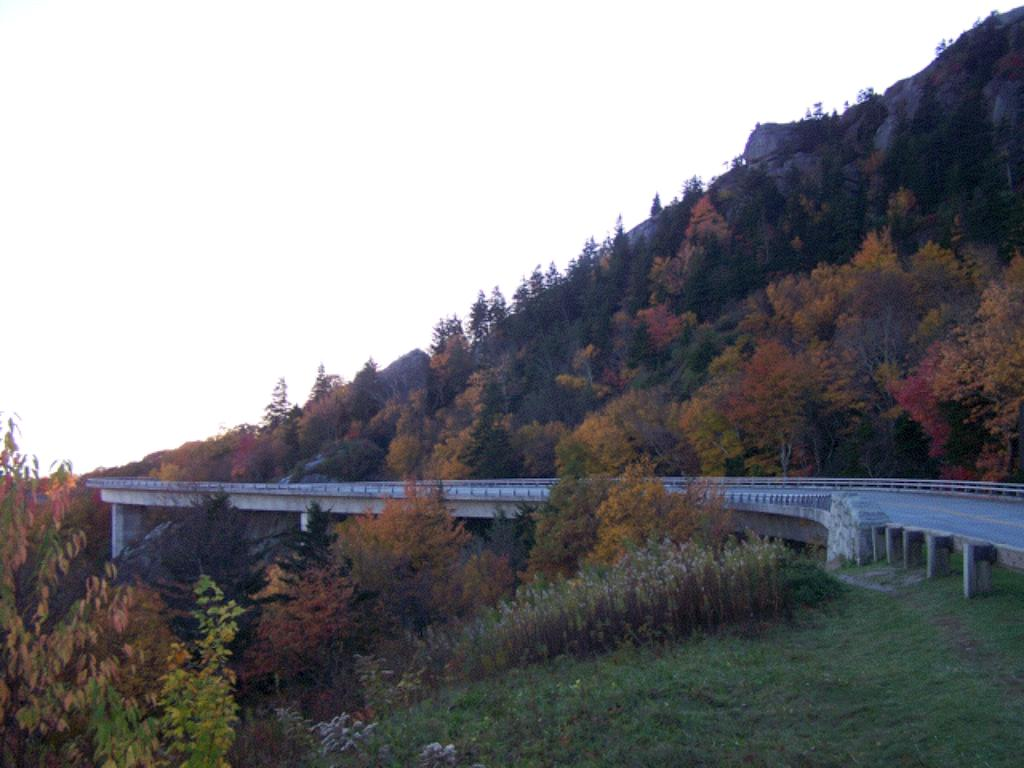What structure is located in the middle of the image? There is a bridge in the middle of the image. What type of vegetation can be seen in the image? There are trees in the image. What is visible at the top of the image? The sky is visible at the top of the image. How many cows are grazing near the bridge in the image? There are no cows present in the image; it features a bridge and trees. What type of partner is visible in the image? There is no partner present in the image; it features a bridge, trees, and the sky. 